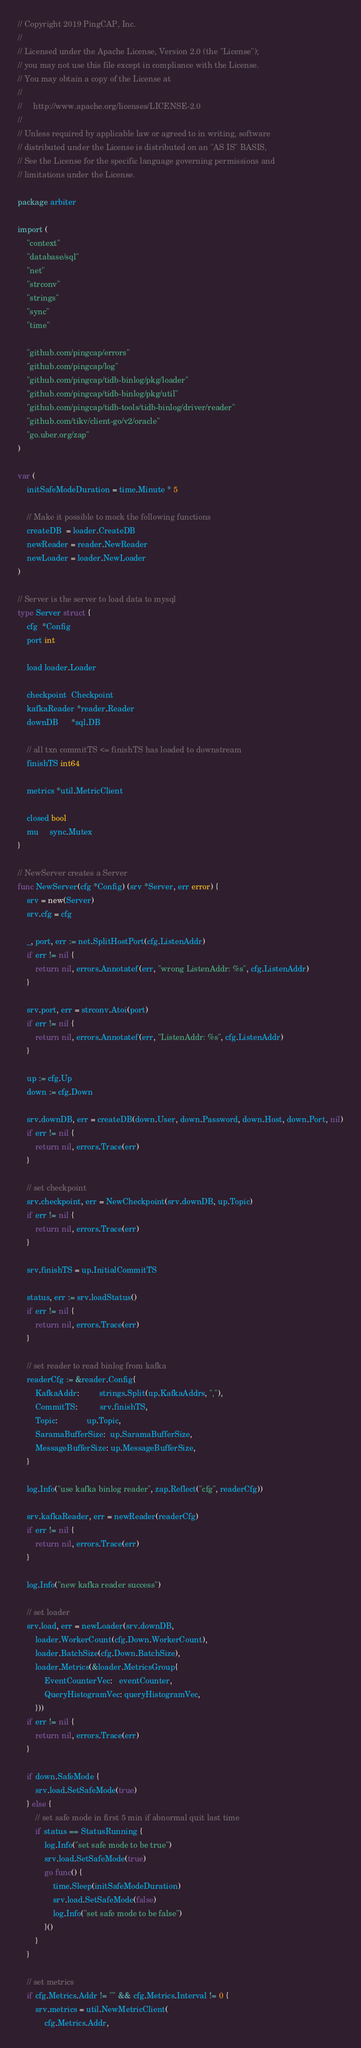<code> <loc_0><loc_0><loc_500><loc_500><_Go_>// Copyright 2019 PingCAP, Inc.
//
// Licensed under the Apache License, Version 2.0 (the "License");
// you may not use this file except in compliance with the License.
// You may obtain a copy of the License at
//
//     http://www.apache.org/licenses/LICENSE-2.0
//
// Unless required by applicable law or agreed to in writing, software
// distributed under the License is distributed on an "AS IS" BASIS,
// See the License for the specific language governing permissions and
// limitations under the License.

package arbiter

import (
	"context"
	"database/sql"
	"net"
	"strconv"
	"strings"
	"sync"
	"time"

	"github.com/pingcap/errors"
	"github.com/pingcap/log"
	"github.com/pingcap/tidb-binlog/pkg/loader"
	"github.com/pingcap/tidb-binlog/pkg/util"
	"github.com/pingcap/tidb-tools/tidb-binlog/driver/reader"
	"github.com/tikv/client-go/v2/oracle"
	"go.uber.org/zap"
)

var (
	initSafeModeDuration = time.Minute * 5

	// Make it possible to mock the following functions
	createDB  = loader.CreateDB
	newReader = reader.NewReader
	newLoader = loader.NewLoader
)

// Server is the server to load data to mysql
type Server struct {
	cfg  *Config
	port int

	load loader.Loader

	checkpoint  Checkpoint
	kafkaReader *reader.Reader
	downDB      *sql.DB

	// all txn commitTS <= finishTS has loaded to downstream
	finishTS int64

	metrics *util.MetricClient

	closed bool
	mu     sync.Mutex
}

// NewServer creates a Server
func NewServer(cfg *Config) (srv *Server, err error) {
	srv = new(Server)
	srv.cfg = cfg

	_, port, err := net.SplitHostPort(cfg.ListenAddr)
	if err != nil {
		return nil, errors.Annotatef(err, "wrong ListenAddr: %s", cfg.ListenAddr)
	}

	srv.port, err = strconv.Atoi(port)
	if err != nil {
		return nil, errors.Annotatef(err, "ListenAddr: %s", cfg.ListenAddr)
	}

	up := cfg.Up
	down := cfg.Down

	srv.downDB, err = createDB(down.User, down.Password, down.Host, down.Port, nil)
	if err != nil {
		return nil, errors.Trace(err)
	}

	// set checkpoint
	srv.checkpoint, err = NewCheckpoint(srv.downDB, up.Topic)
	if err != nil {
		return nil, errors.Trace(err)
	}

	srv.finishTS = up.InitialCommitTS

	status, err := srv.loadStatus()
	if err != nil {
		return nil, errors.Trace(err)
	}

	// set reader to read binlog from kafka
	readerCfg := &reader.Config{
		KafkaAddr:         strings.Split(up.KafkaAddrs, ","),
		CommitTS:          srv.finishTS,
		Topic:             up.Topic,
		SaramaBufferSize:  up.SaramaBufferSize,
		MessageBufferSize: up.MessageBufferSize,
	}

	log.Info("use kafka binlog reader", zap.Reflect("cfg", readerCfg))

	srv.kafkaReader, err = newReader(readerCfg)
	if err != nil {
		return nil, errors.Trace(err)
	}

	log.Info("new kafka reader success")

	// set loader
	srv.load, err = newLoader(srv.downDB,
		loader.WorkerCount(cfg.Down.WorkerCount),
		loader.BatchSize(cfg.Down.BatchSize),
		loader.Metrics(&loader.MetricsGroup{
			EventCounterVec:   eventCounter,
			QueryHistogramVec: queryHistogramVec,
		}))
	if err != nil {
		return nil, errors.Trace(err)
	}

	if down.SafeMode {
		srv.load.SetSafeMode(true)
	} else {
		// set safe mode in first 5 min if abnormal quit last time
		if status == StatusRunning {
			log.Info("set safe mode to be true")
			srv.load.SetSafeMode(true)
			go func() {
				time.Sleep(initSafeModeDuration)
				srv.load.SetSafeMode(false)
				log.Info("set safe mode to be false")
			}()
		}
	}

	// set metrics
	if cfg.Metrics.Addr != "" && cfg.Metrics.Interval != 0 {
		srv.metrics = util.NewMetricClient(
			cfg.Metrics.Addr,</code> 